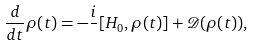Convert formula to latex. <formula><loc_0><loc_0><loc_500><loc_500>\frac { d } { d t } \rho ( t ) = - \frac { i } { } [ H _ { 0 } , \rho ( t ) ] + { \mathcal { D } } ( \rho ( t ) ) ,</formula> 